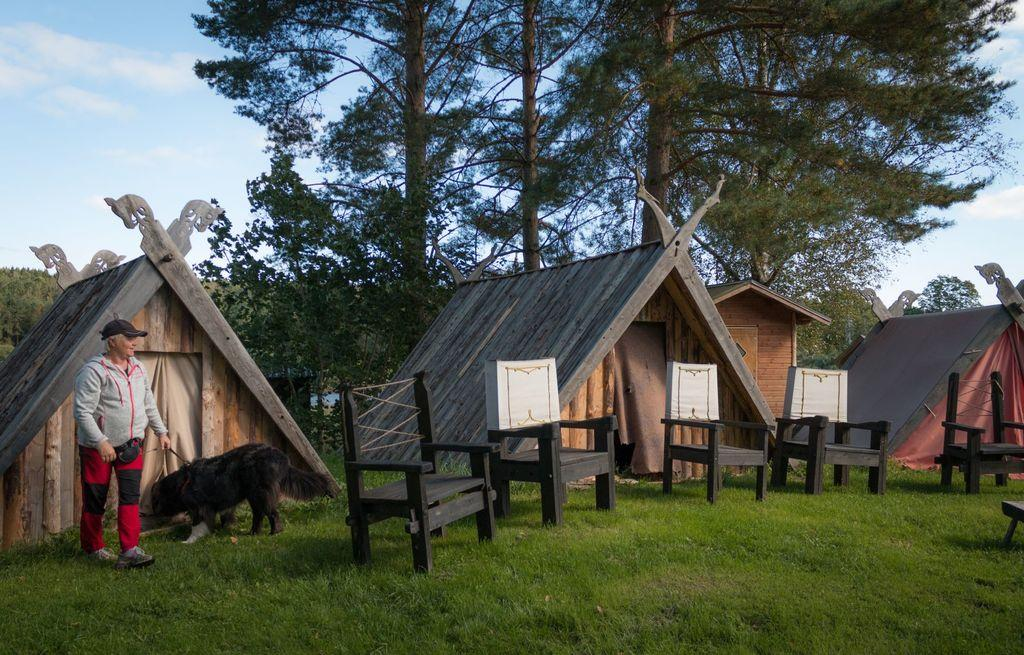What type of vegetation is present in the image? There is grass in the image. What type of furniture can be seen in the image? There are chairs in the image. What is the woman in the image doing? The woman is holding a dog in the image. What can be seen in the distance in the image? There are houses and trees in the background of the image. What is visible in the sky in the background of the image? There are clouds in the sky in the background of the image. What type of brass instrument is the woman playing with the dog in the image? There is: There is no brass instrument present in the image; the woman is simply holding a dog. Can you tell me how many worms are crawling on the grass in the image? There are no worms visible in the image; it only shows grass, chairs, a woman holding a dog, and the background elements. 